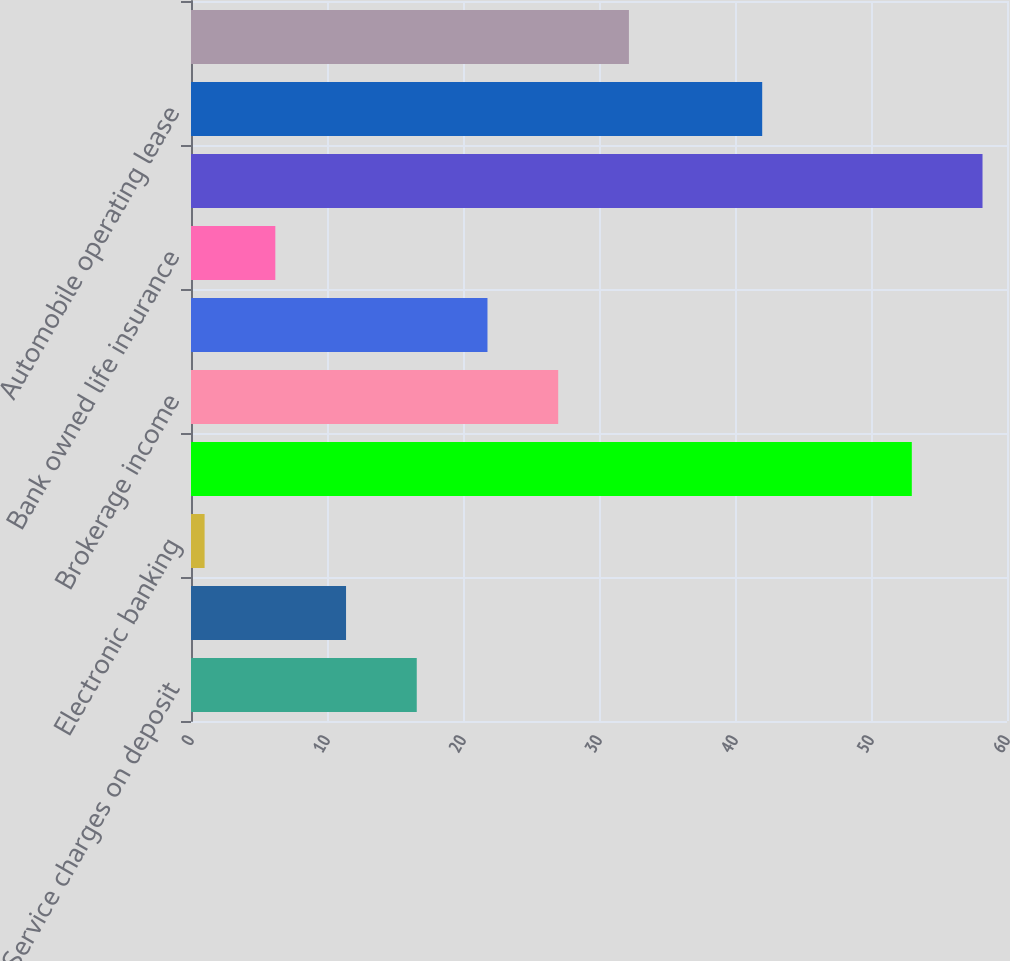Convert chart. <chart><loc_0><loc_0><loc_500><loc_500><bar_chart><fcel>Service charges on deposit<fcel>Trust services<fcel>Electronic banking<fcel>Mortgage banking income<fcel>Brokerage income<fcel>Insurance income<fcel>Bank owned life insurance<fcel>Capital markets fees<fcel>Automobile operating lease<fcel>Other income<nl><fcel>16.6<fcel>11.4<fcel>1<fcel>53<fcel>27<fcel>21.8<fcel>6.2<fcel>58.2<fcel>42<fcel>32.2<nl></chart> 